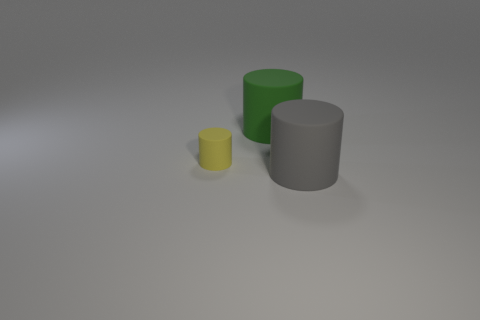What number of cylinders are the same material as the big gray object? There are two cylinders that appear to be made of the same matte material as the large gray cylinder. 